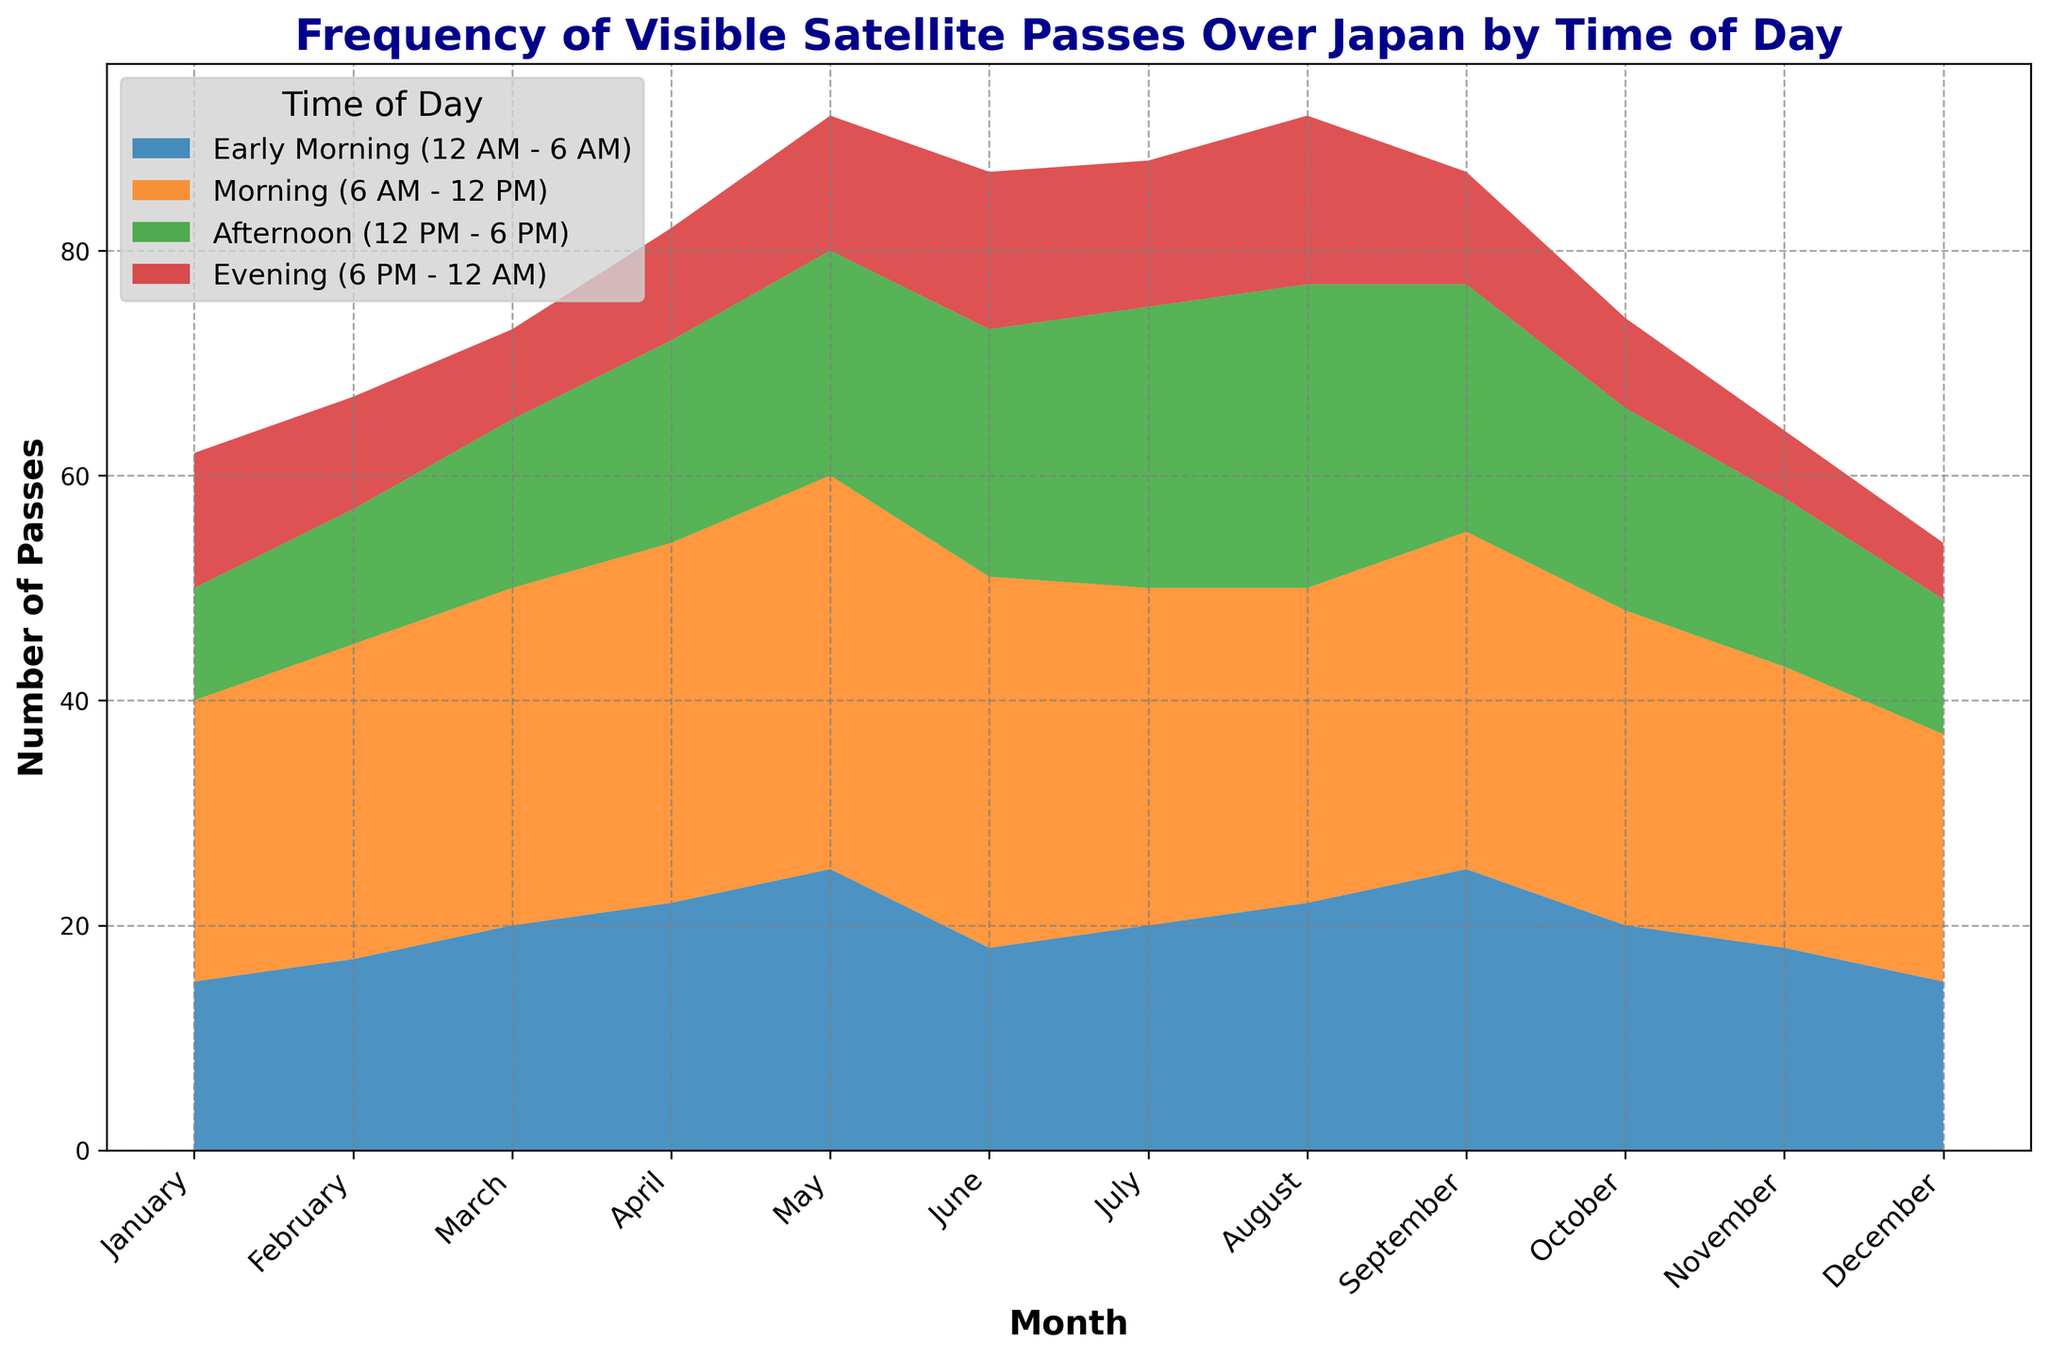Which month has the highest number of visible satellite passes in the Early Morning category? By looking at the plot, identify the month with the highest region in the Early Morning (12 AM - 6 AM) category. This month's value is clearly distinct.
Answer: May Which category consistently shows an increase in the number of visible satellite passes from January to March? Inspect the plot to track the trend for each category from January to March to see which category displays a steady increase over these months.
Answer: Morning In which month is the total number of visible satellite passes the highest? To determine the month with the highest total number of visible satellite passes, sum up the values of all four time categories for each month and identify the month with the highest total.
Answer: May During what time of day do satellites have the highest cumulative passes throughout the year? Sum the values for each time category across all months and compare the totals to find the category with the highest cumulative passes.
Answer: Morning Among all the time categories, which month shows the maximum decrease in the Evening category compared to the previous month? Examine the Evening (6 PM - 12 AM) category and identify the month where the difference from the previous month's passes is largest.
Answer: November Which category shows the smallest variation in visible satellite passes throughout the year? By visually inspecting the plot for each category, look for the one with the least fluctuation between the peaks and troughs across all months.
Answer: Evening What is the average number of visible satellite passes in the Afternoon (12 PM - 6 PM) category across the entire year? Add up all the values in the Afternoon (12 PM - 6 PM) category and divide by the number of months (12) to find the average.
Answer: 17.5 Which month experiences the smallest number of visible satellite passes in the Morning category? By visually comparing the Morning (6 AM - 12 PM) category over the months, identify the month with the lowest point.
Answer: December Is there a month where the total number of visible satellite passes is less than 50? For each month, sum the visible satellite passes for all categories and check if any month has a total number less than 50.
Answer: No How does the frequency of visible satellite passes in the Early Morning category for July compare to that of January? Compare the height of the regions representing Early Morning (12 AM - 6 AM) in July and January to determine their relative frequencies.
Answer: Higher in July 